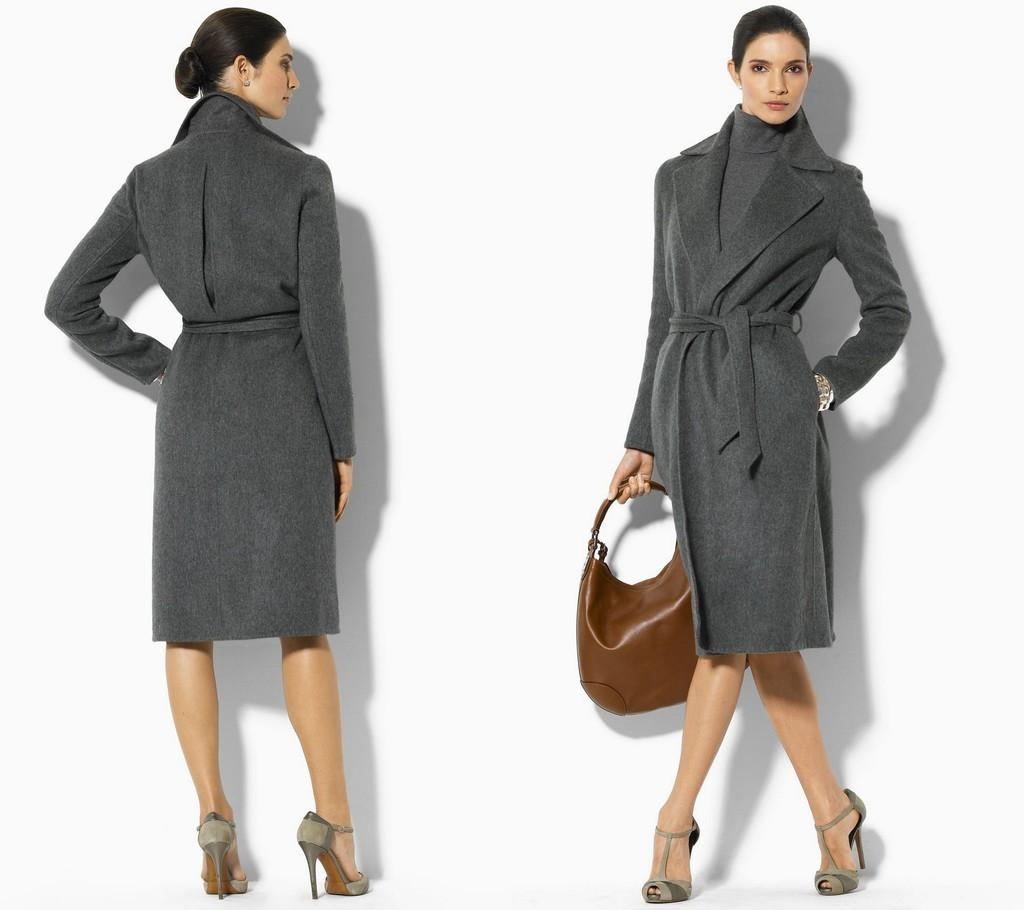How many people are in the image? There are two persons in the image. What color are the dresses of the people in the image? The two persons are wearing grey color dresses. What is one person holding in the image? One person is holding a brown color bag. What color is the background of the image? The background of the image is white. What type of tin can be seen in the image? There is no tin present in the image. Are the two persons in the image planning a vacation? The image does not provide any information about the plans or intentions of the two persons, so it cannot be determined if they are planning a vacation. What type of loss is depicted in the image? There is no loss depicted in the image; it features two people wearing grey dresses and one person holding a brown color bag. 